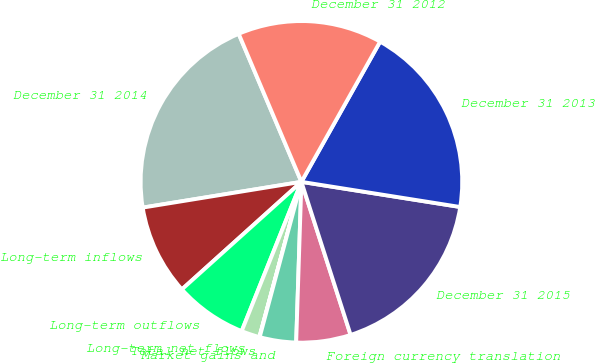Convert chart to OTSL. <chart><loc_0><loc_0><loc_500><loc_500><pie_chart><fcel>December 31 2014<fcel>Long-term inflows<fcel>Long-term outflows<fcel>Long-term net flows<fcel>Total net flows<fcel>Market gains and<fcel>Foreign currency translation<fcel>December 31 2015<fcel>December 31 2013<fcel>December 31 2012<nl><fcel>21.18%<fcel>9.1%<fcel>7.28%<fcel>1.85%<fcel>0.03%<fcel>3.66%<fcel>5.47%<fcel>17.55%<fcel>19.36%<fcel>14.52%<nl></chart> 